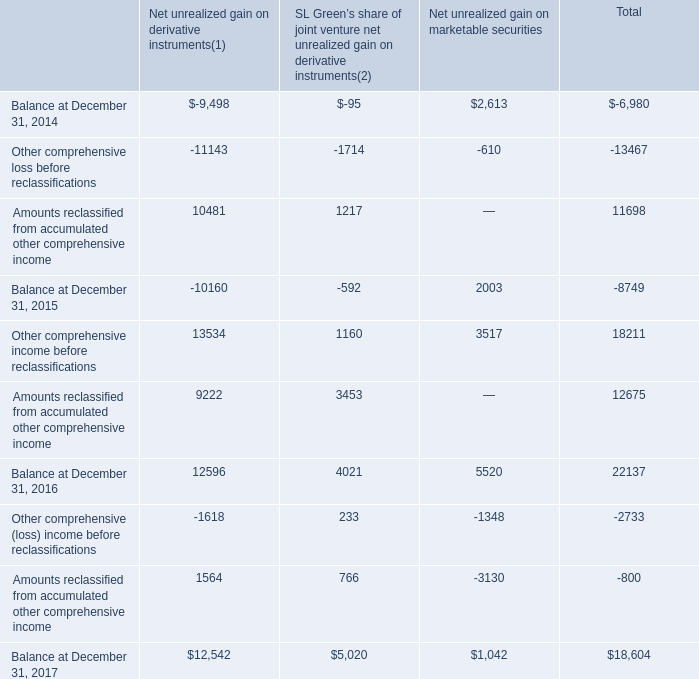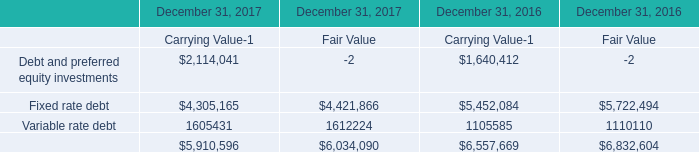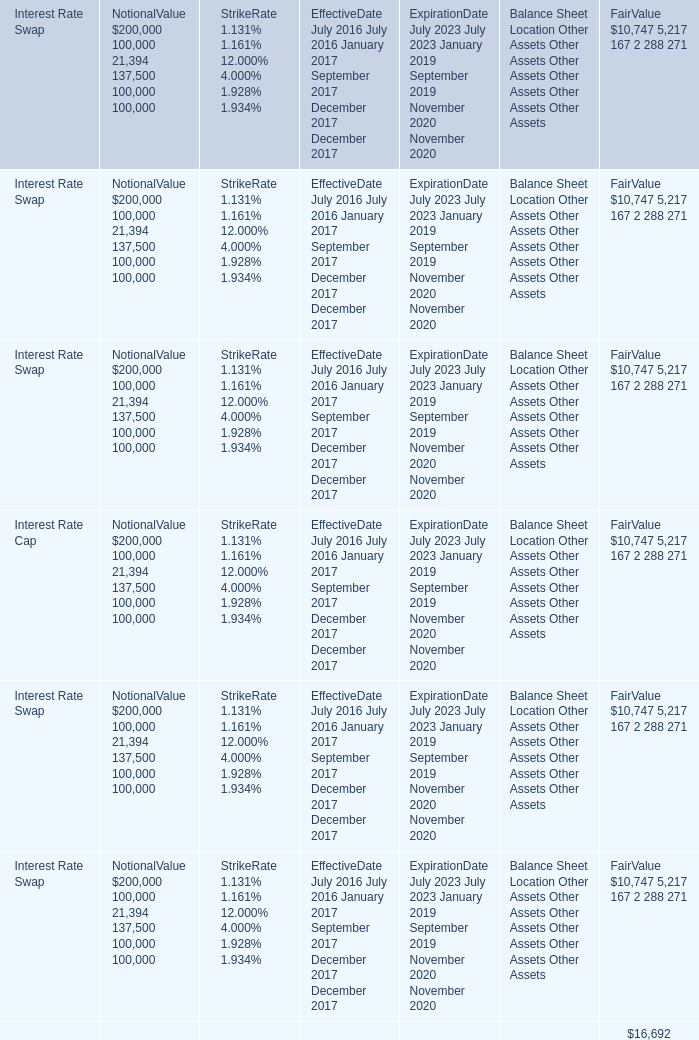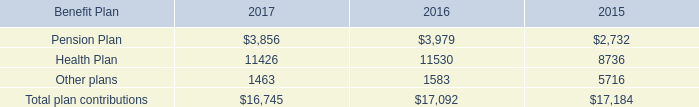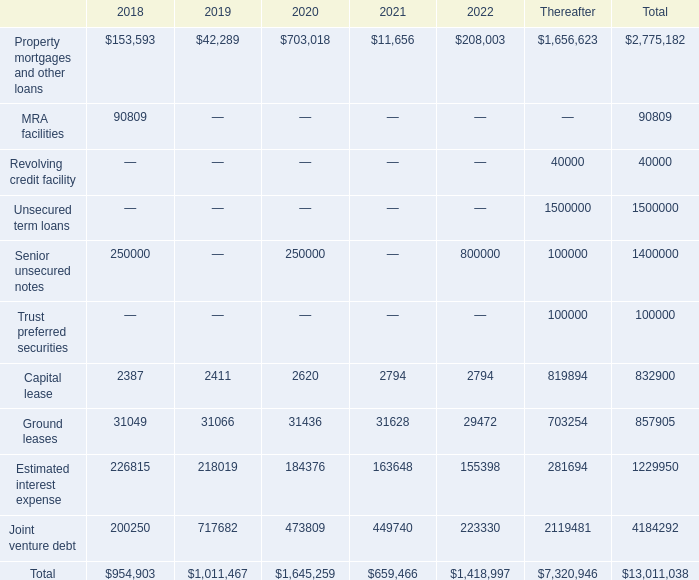What is the sum of Ground leases of 2020, Health Plan of 2016, and Property mortgages and other loans of Thereafter ? 
Computations: ((31436.0 + 11530.0) + 1656623.0)
Answer: 1699589.0. 